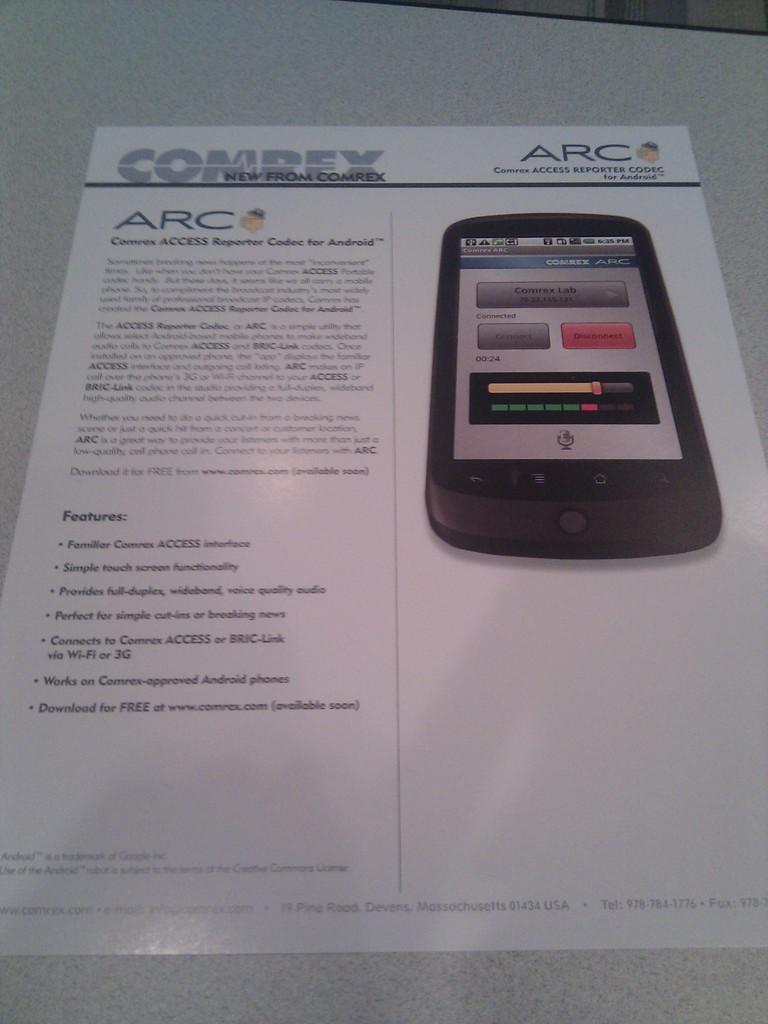What brand is this for?
Your response must be concise. Comrex. What is the last feature listed?
Ensure brevity in your answer.  Download for free. 